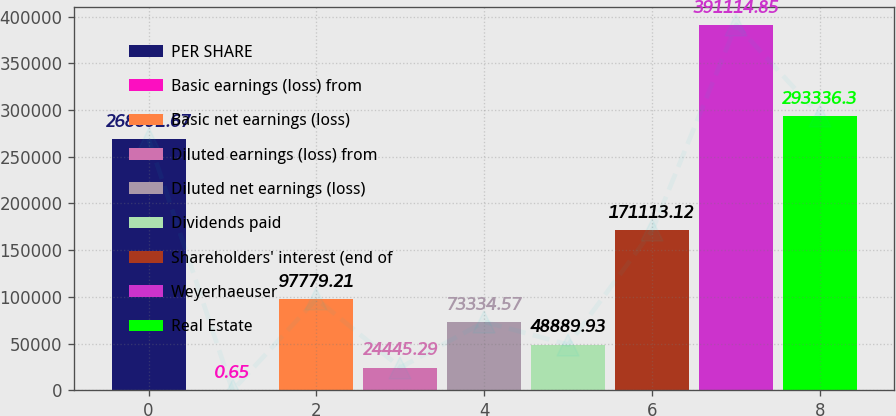Convert chart to OTSL. <chart><loc_0><loc_0><loc_500><loc_500><bar_chart><fcel>PER SHARE<fcel>Basic earnings (loss) from<fcel>Basic net earnings (loss)<fcel>Diluted earnings (loss) from<fcel>Diluted net earnings (loss)<fcel>Dividends paid<fcel>Shareholders' interest (end of<fcel>Weyerhaeuser<fcel>Real Estate<nl><fcel>268892<fcel>0.65<fcel>97779.2<fcel>24445.3<fcel>73334.6<fcel>48889.9<fcel>171113<fcel>391115<fcel>293336<nl></chart> 